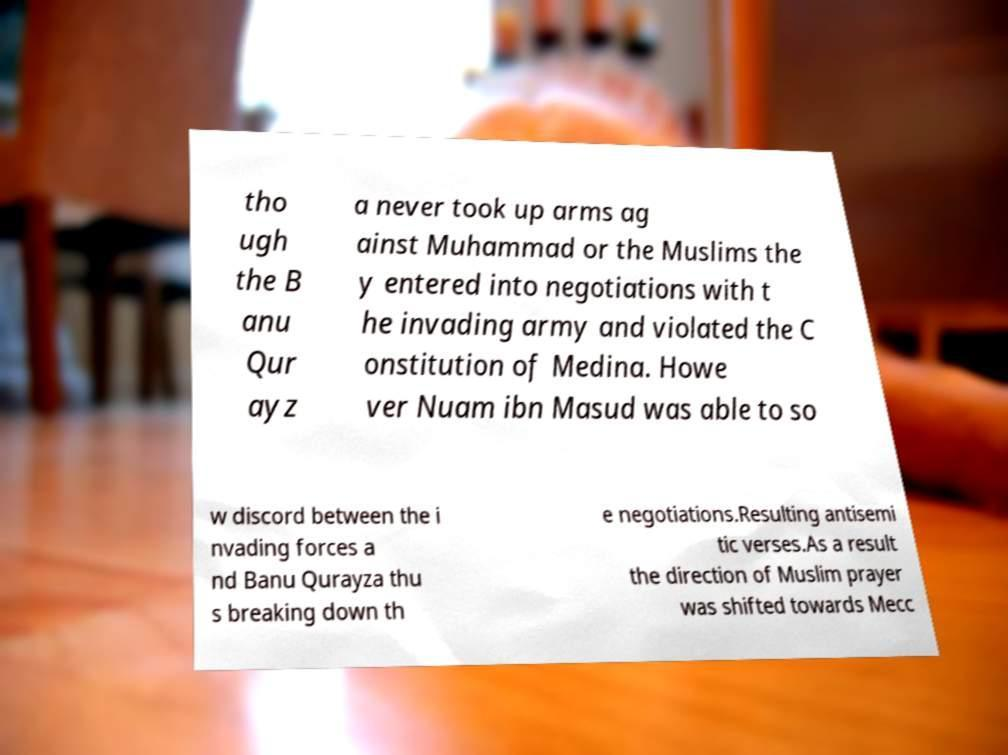Could you assist in decoding the text presented in this image and type it out clearly? tho ugh the B anu Qur ayz a never took up arms ag ainst Muhammad or the Muslims the y entered into negotiations with t he invading army and violated the C onstitution of Medina. Howe ver Nuam ibn Masud was able to so w discord between the i nvading forces a nd Banu Qurayza thu s breaking down th e negotiations.Resulting antisemi tic verses.As a result the direction of Muslim prayer was shifted towards Mecc 